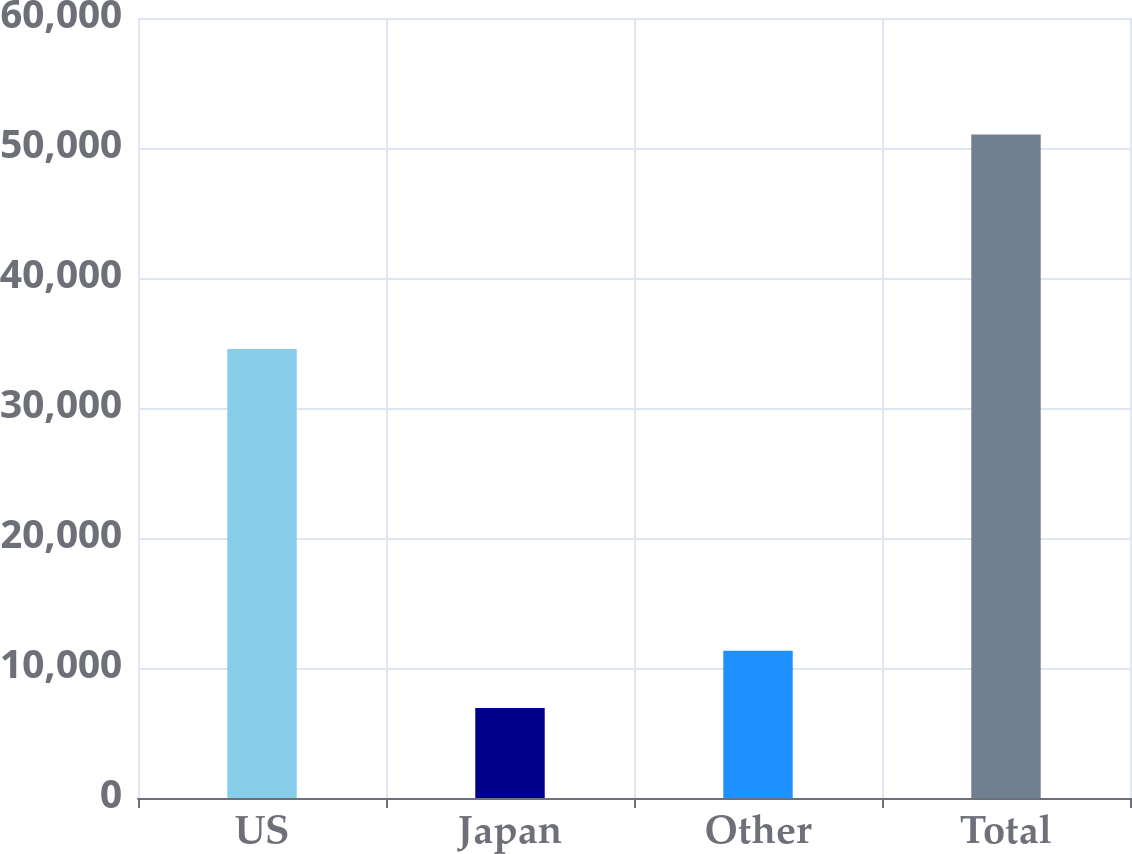Convert chart. <chart><loc_0><loc_0><loc_500><loc_500><bar_chart><fcel>US<fcel>Japan<fcel>Other<fcel>Total<nl><fcel>34536<fcel>6917<fcel>11329.6<fcel>51043<nl></chart> 